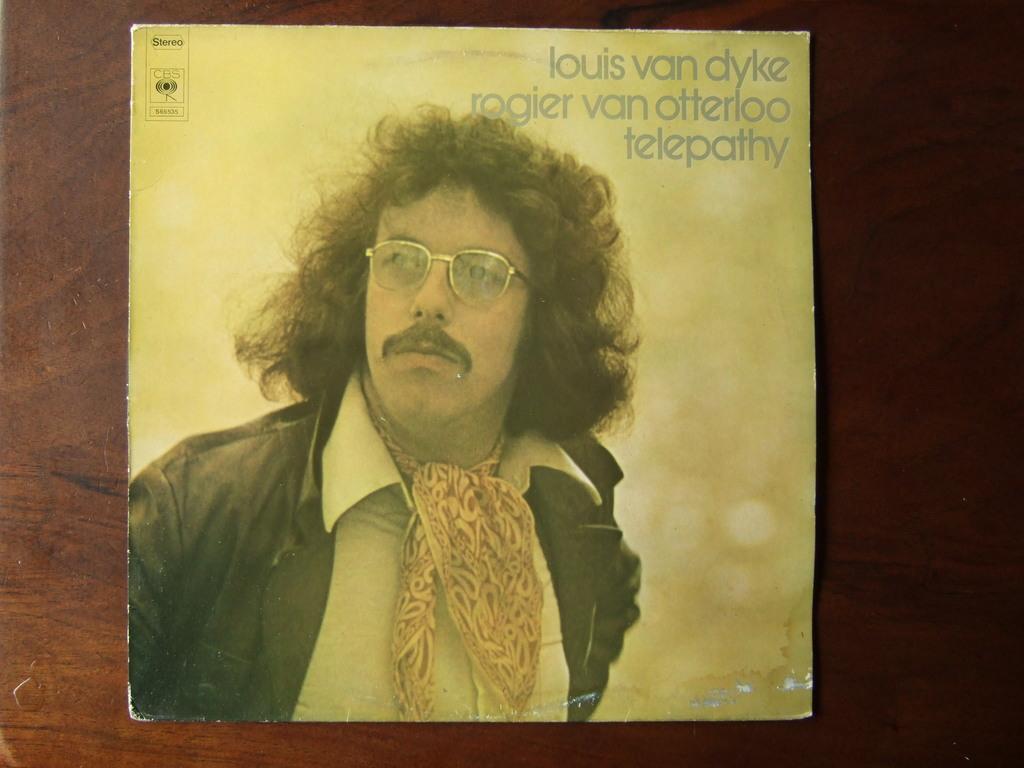Could you give a brief overview of what you see in this image? In this picture there is a cardboard which has a picture of a person wearing black jacket on it and there is something written above it. 